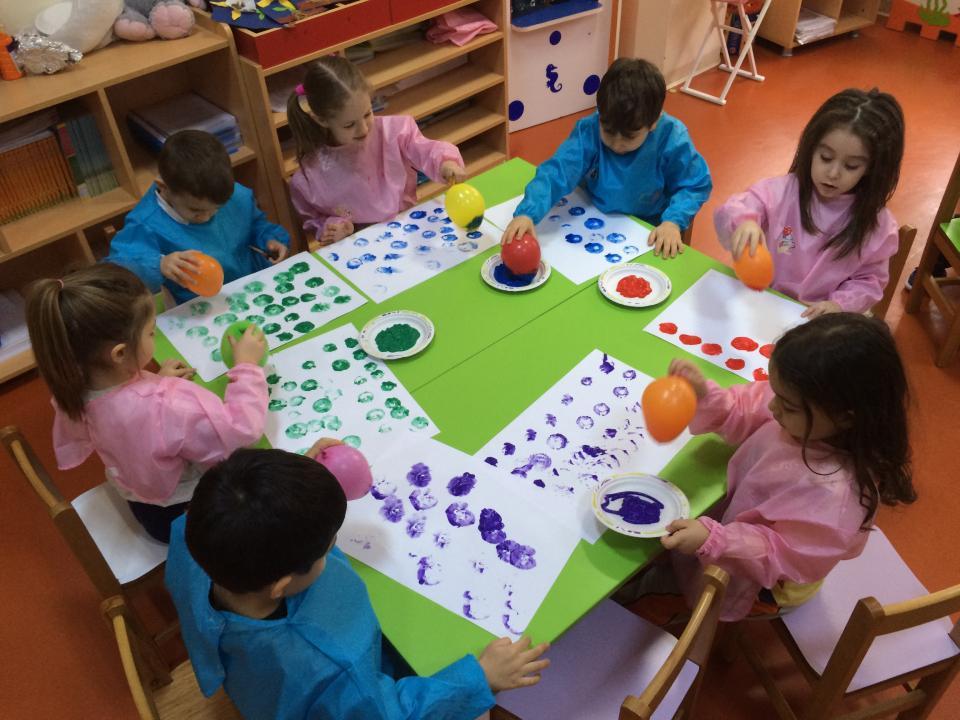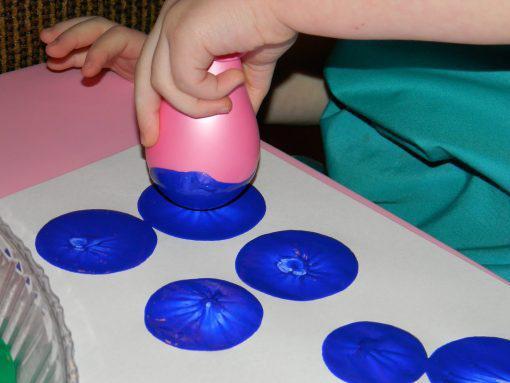The first image is the image on the left, the second image is the image on the right. Given the left and right images, does the statement "There are multiple children's heads visible." hold true? Answer yes or no. Yes. The first image is the image on the left, the second image is the image on the right. Considering the images on both sides, is "The left image contains at least two children." valid? Answer yes or no. Yes. 